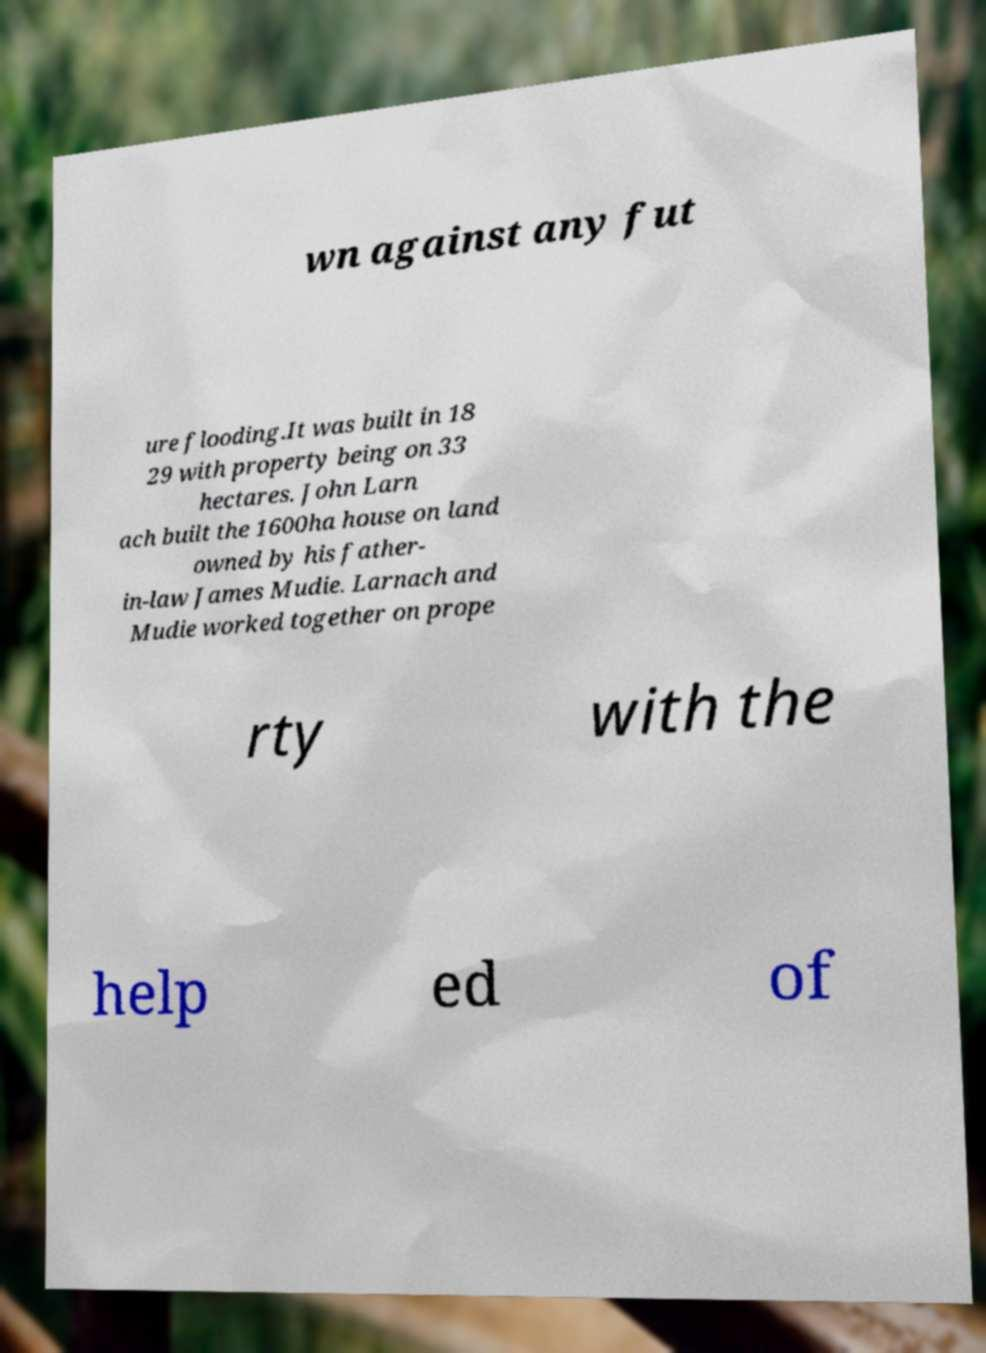Can you read and provide the text displayed in the image?This photo seems to have some interesting text. Can you extract and type it out for me? wn against any fut ure flooding.It was built in 18 29 with property being on 33 hectares. John Larn ach built the 1600ha house on land owned by his father- in-law James Mudie. Larnach and Mudie worked together on prope rty with the help ed of 